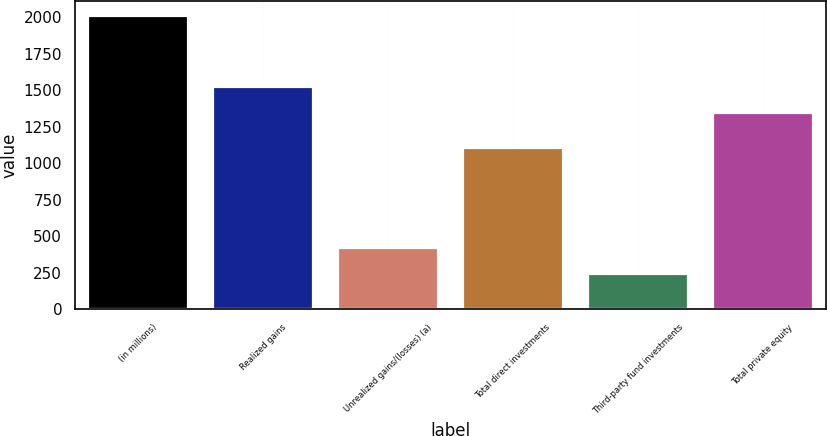Convert chart. <chart><loc_0><loc_0><loc_500><loc_500><bar_chart><fcel>(in millions)<fcel>Realized gains<fcel>Unrealized gains/(losses) (a)<fcel>Total direct investments<fcel>Third-party fund investments<fcel>Total private equity<nl><fcel>2010<fcel>1524.9<fcel>417.9<fcel>1107<fcel>241<fcel>1348<nl></chart> 